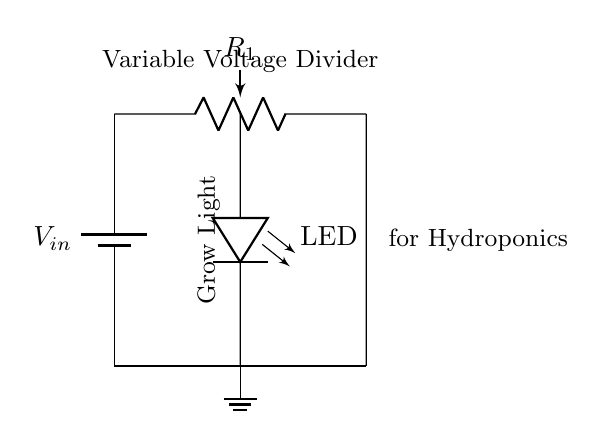What is the input voltage in this circuit? The input voltage, denoted as V_in, is represented by the battery in the circuit diagram. It provides the voltage supply for the circuit.
Answer: V_in What component is used to control the LED brightness? The circuit uses a potentiometer, labeled as R1, to adjust the resistance and thereby control the brightness of the LED connected in parallel.
Answer: Potentiometer Where is the LED located in relation to the battery? The LED is placed in a vertical position and connected in parallel to the potentiometer, making it directly between the input voltage and ground.
Answer: Parallel to the potentiometer What is the role of the ground in this circuit? The ground provides a common return path for the electric current, establishing a reference point for the voltage measurements in the circuit, enabling proper function.
Answer: Common reference point How does adjusting the potentiometer affect the LED? Adjusting the potentiometer changes the resistance in the circuit, which alters the current flowing through the LED, thus varying its brightness based on resistance value.
Answer: Changes brightness What type of circuit configuration is this? This circuit is a voltage divider configuration, where the output voltage across the LED is a fraction of the input voltage, controlled by the potentiometer.
Answer: Voltage divider 